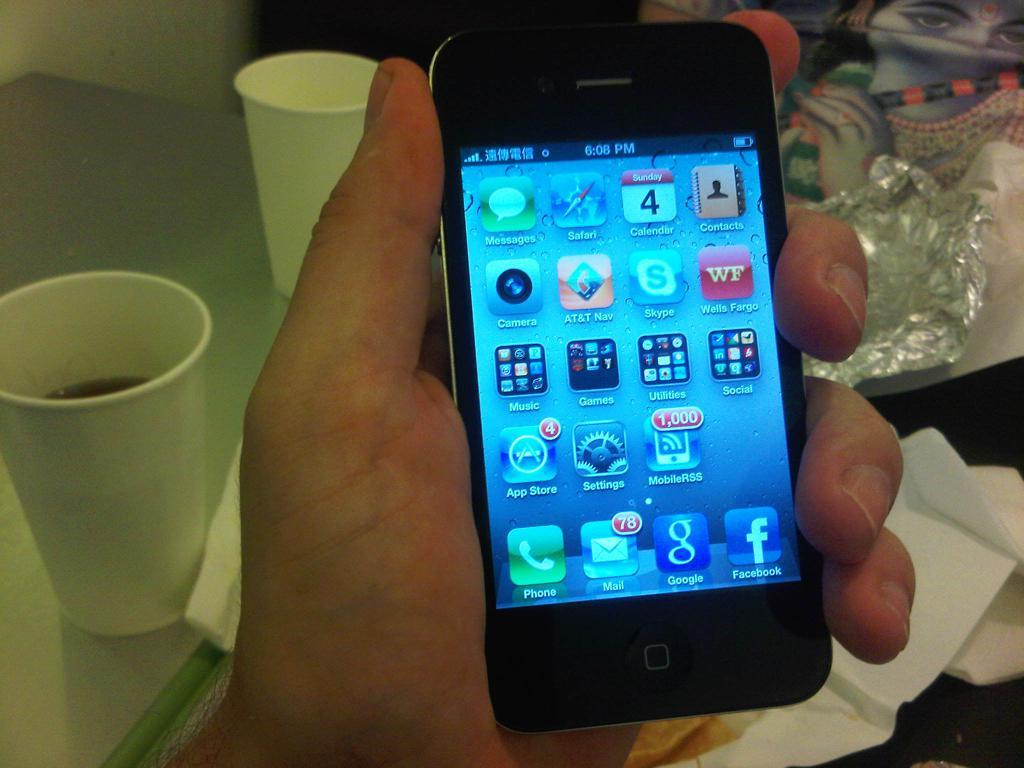Provide a one-sentence caption for the provided image. A hand holds a smartphone with a bunch of different icons on it. 